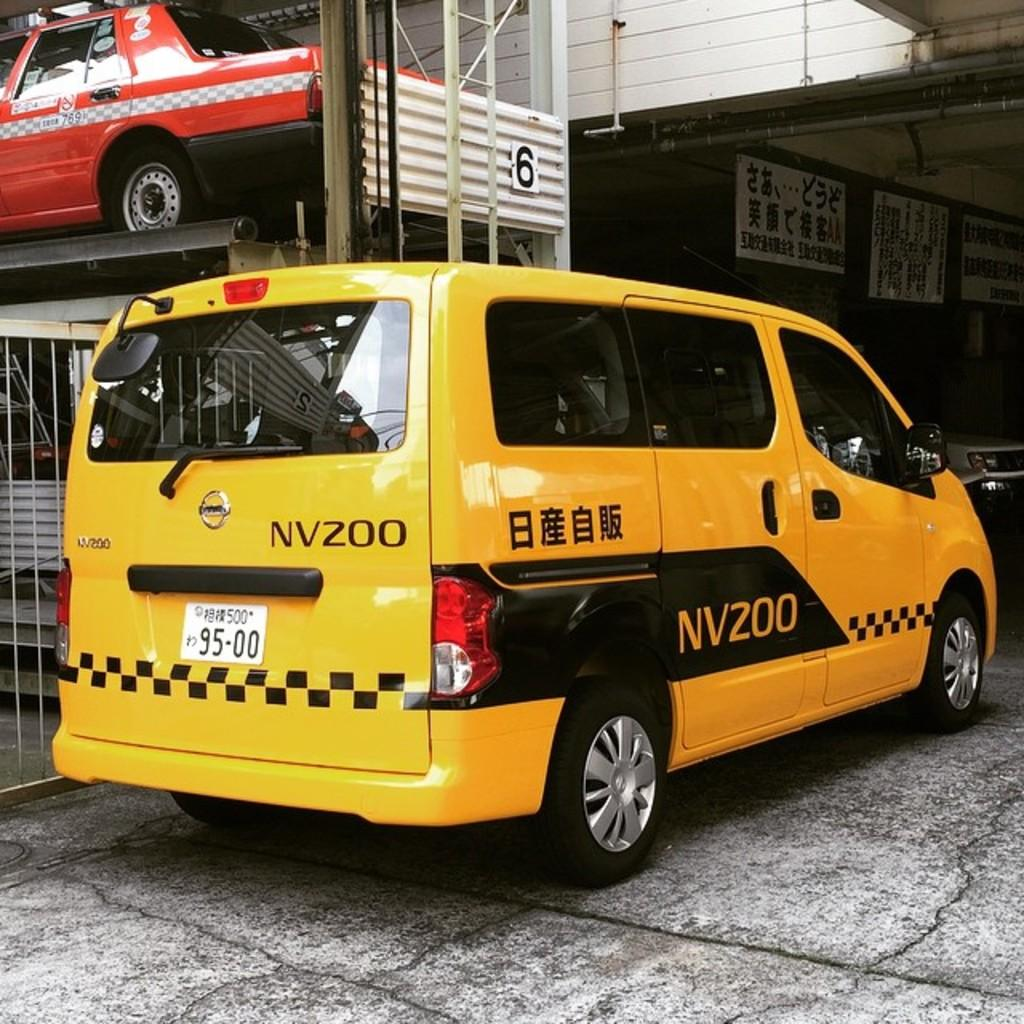What can be seen in the middle of the image? There are two cars in the middle of the image. What is visible in the background of the image? There are posters and a wall in the background of the image. What is located on the left side of the image? There is a fence on the left side of the image. What type of knee injury can be seen in the image? There is no knee injury present in the image. What is the glass used for in the image? There is no glass present in the image. 